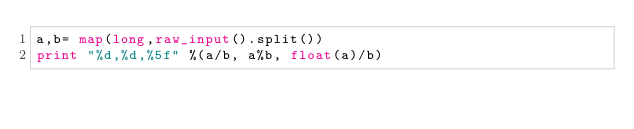Convert code to text. <code><loc_0><loc_0><loc_500><loc_500><_Python_>a,b= map(long,raw_input().split())
print "%d,%d,%5f" %(a/b, a%b, float(a)/b)</code> 